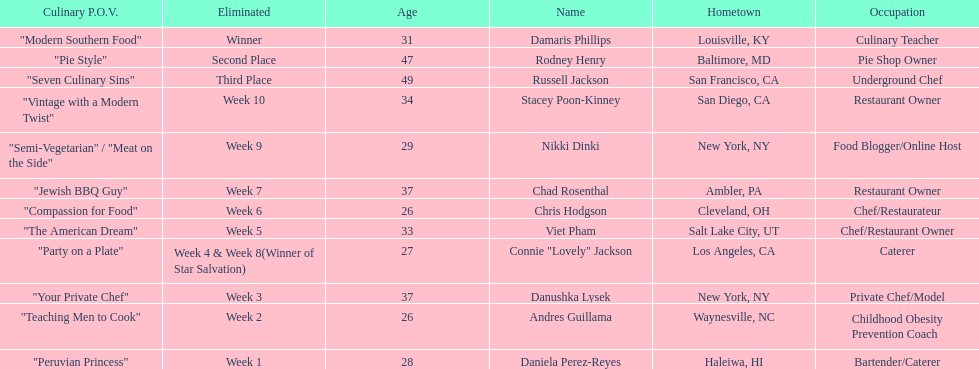Parse the table in full. {'header': ['Culinary P.O.V.', 'Eliminated', 'Age', 'Name', 'Hometown', 'Occupation'], 'rows': [['"Modern Southern Food"', 'Winner', '31', 'Damaris Phillips', 'Louisville, KY', 'Culinary Teacher'], ['"Pie Style"', 'Second Place', '47', 'Rodney Henry', 'Baltimore, MD', 'Pie Shop Owner'], ['"Seven Culinary Sins"', 'Third Place', '49', 'Russell Jackson', 'San Francisco, CA', 'Underground Chef'], ['"Vintage with a Modern Twist"', 'Week 10', '34', 'Stacey Poon-Kinney', 'San Diego, CA', 'Restaurant Owner'], ['"Semi-Vegetarian" / "Meat on the Side"', 'Week 9', '29', 'Nikki Dinki', 'New York, NY', 'Food Blogger/Online Host'], ['"Jewish BBQ Guy"', 'Week 7', '37', 'Chad Rosenthal', 'Ambler, PA', 'Restaurant Owner'], ['"Compassion for Food"', 'Week 6', '26', 'Chris Hodgson', 'Cleveland, OH', 'Chef/Restaurateur'], ['"The American Dream"', 'Week 5', '33', 'Viet Pham', 'Salt Lake City, UT', 'Chef/Restaurant Owner'], ['"Party on a Plate"', 'Week 4 & Week 8(Winner of Star Salvation)', '27', 'Connie "Lovely" Jackson', 'Los Angeles, CA', 'Caterer'], ['"Your Private Chef"', 'Week 3', '37', 'Danushka Lysek', 'New York, NY', 'Private Chef/Model'], ['"Teaching Men to Cook"', 'Week 2', '26', 'Andres Guillama', 'Waynesville, NC', 'Childhood Obesity Prevention Coach'], ['"Peruvian Princess"', 'Week 1', '28', 'Daniela Perez-Reyes', 'Haleiwa, HI', 'Bartender/Caterer']]} Who was the top chef? Damaris Phillips. 